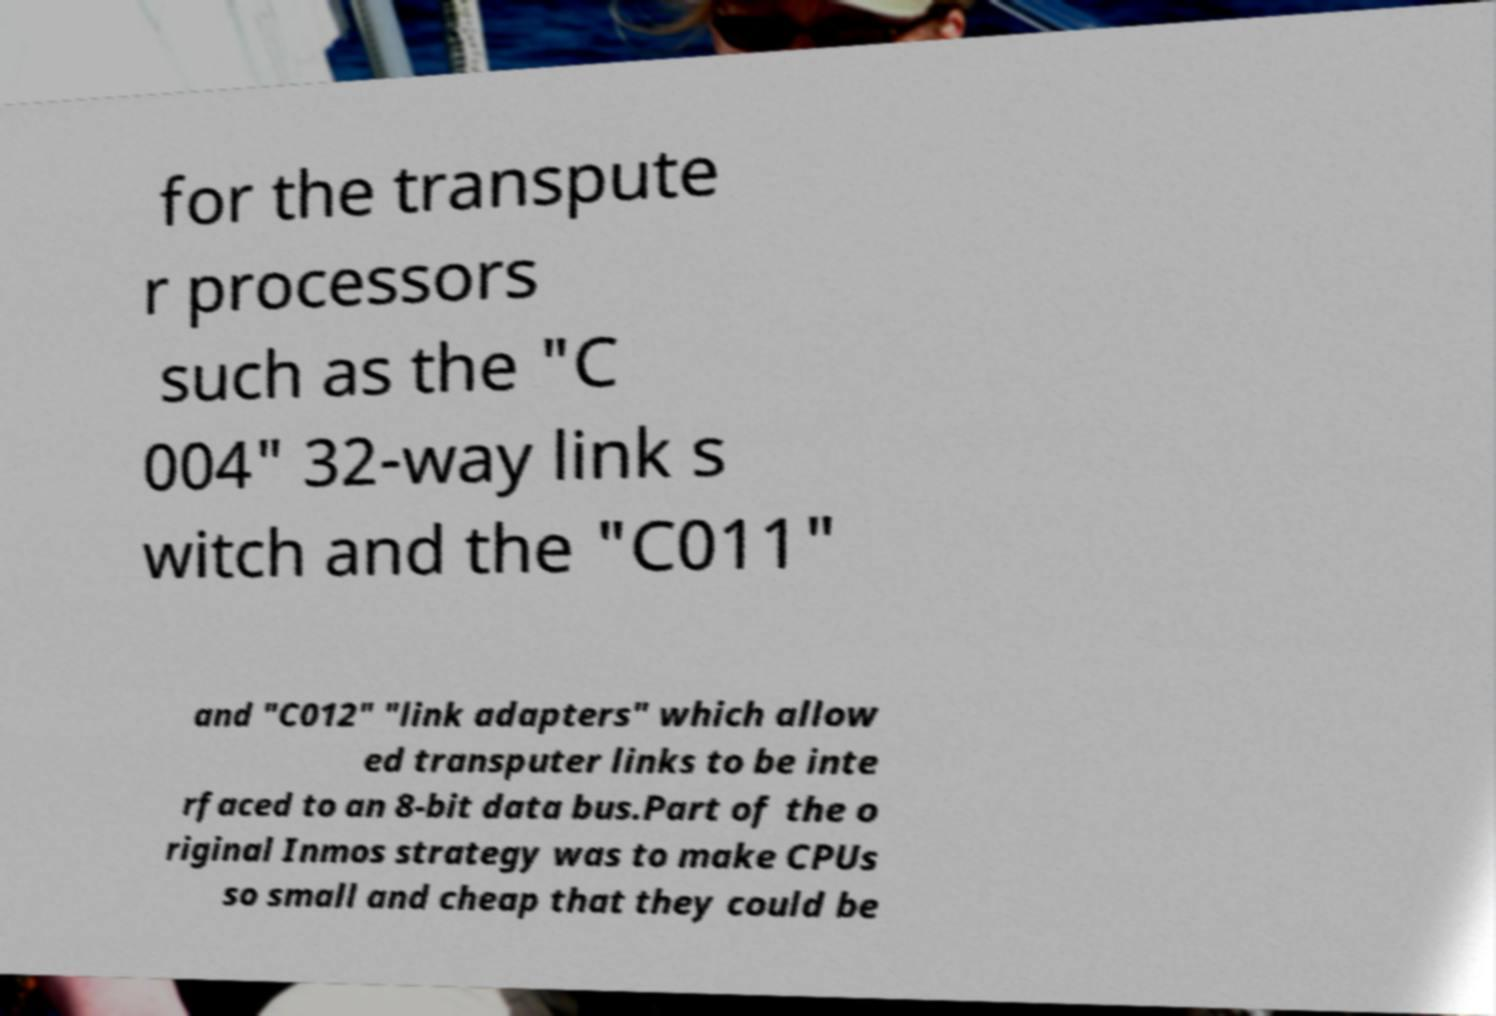Please identify and transcribe the text found in this image. for the transpute r processors such as the "C 004" 32-way link s witch and the "C011" and "C012" "link adapters" which allow ed transputer links to be inte rfaced to an 8-bit data bus.Part of the o riginal Inmos strategy was to make CPUs so small and cheap that they could be 